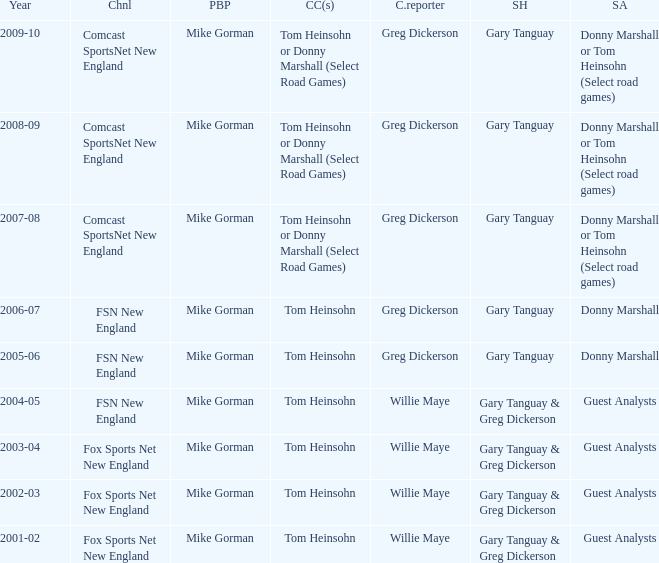How many channels were the games shown on in 2001-02? 1.0. 